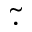<formula> <loc_0><loc_0><loc_500><loc_500>\tilde { \cdot }</formula> 